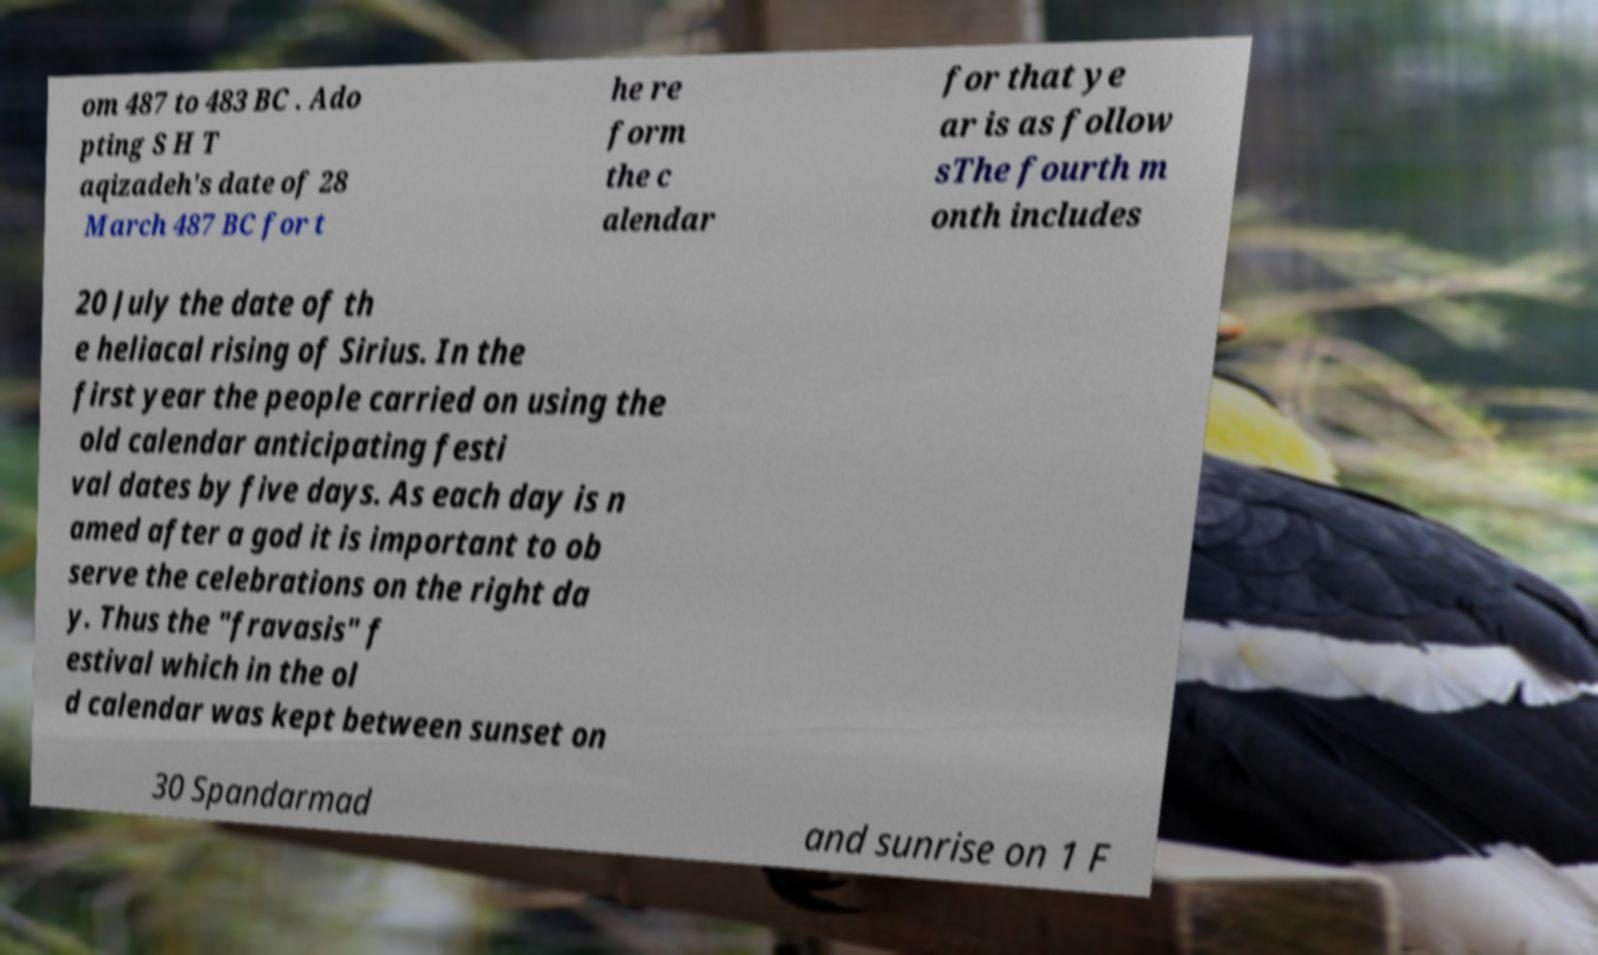Please read and relay the text visible in this image. What does it say? om 487 to 483 BC . Ado pting S H T aqizadeh's date of 28 March 487 BC for t he re form the c alendar for that ye ar is as follow sThe fourth m onth includes 20 July the date of th e heliacal rising of Sirius. In the first year the people carried on using the old calendar anticipating festi val dates by five days. As each day is n amed after a god it is important to ob serve the celebrations on the right da y. Thus the "fravasis" f estival which in the ol d calendar was kept between sunset on 30 Spandarmad and sunrise on 1 F 